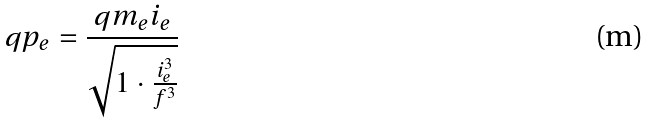Convert formula to latex. <formula><loc_0><loc_0><loc_500><loc_500>q p _ { e } = \frac { q m _ { e } i _ { e } } { \sqrt { 1 \cdot \frac { i _ { e } ^ { 3 } } { f ^ { 3 } } } }</formula> 